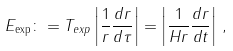<formula> <loc_0><loc_0><loc_500><loc_500>E _ { \exp } \colon = T _ { e x p } \left | \frac { 1 } { r } \frac { d r } { d \tau } \right | = \left | \frac { 1 } { H r } \frac { d r } { d t } \right | \, ,</formula> 